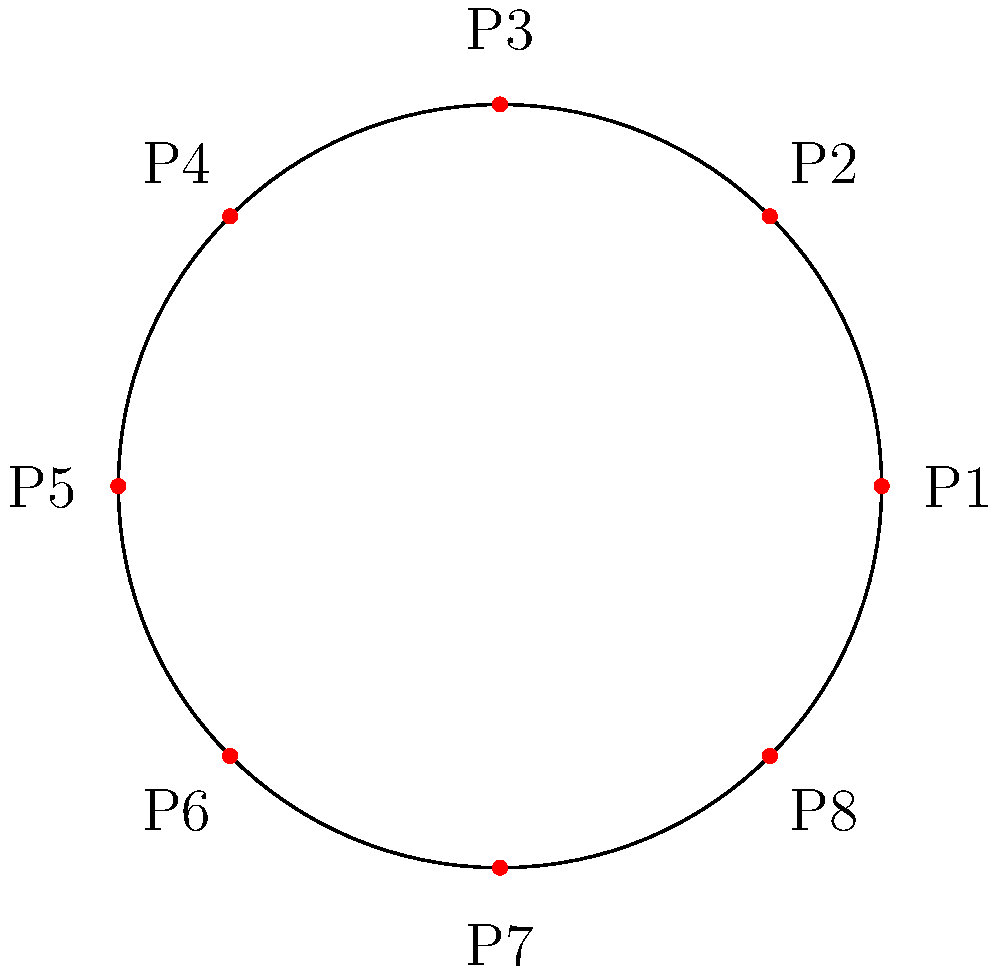You want to arrange 8 movie posters on a circular display board in your cinema lobby. The posters need to be equally spaced around the circle. If the first poster (P1) is placed at $(r, 0)$ in polar coordinates, where $r$ is the radius of the circle, at what polar coordinates $(r, \theta)$ would you place the fifth poster (P5)? To solve this problem, let's follow these steps:

1. Recognize that there are 8 posters in total, so they will be spaced at intervals of $\frac{360°}{8} = 45°$ around the circle.

2. Convert 45° to radians: $45° \times \frac{\pi}{180°} = \frac{\pi}{4}$ radians.

3. The fifth poster (P5) will be positioned 4 intervals away from the first poster (P1), as we count P1, P2, P3, P4, P5.

4. Calculate the angle for P5: $4 \times \frac{\pi}{4} = \pi$ radians.

5. In polar coordinates, the radius $r$ remains constant for all posters as they are all on the circumference of the circle.

6. Therefore, the polar coordinates for P5 will be $(r, \pi)$.
Answer: $(r, \pi)$ 